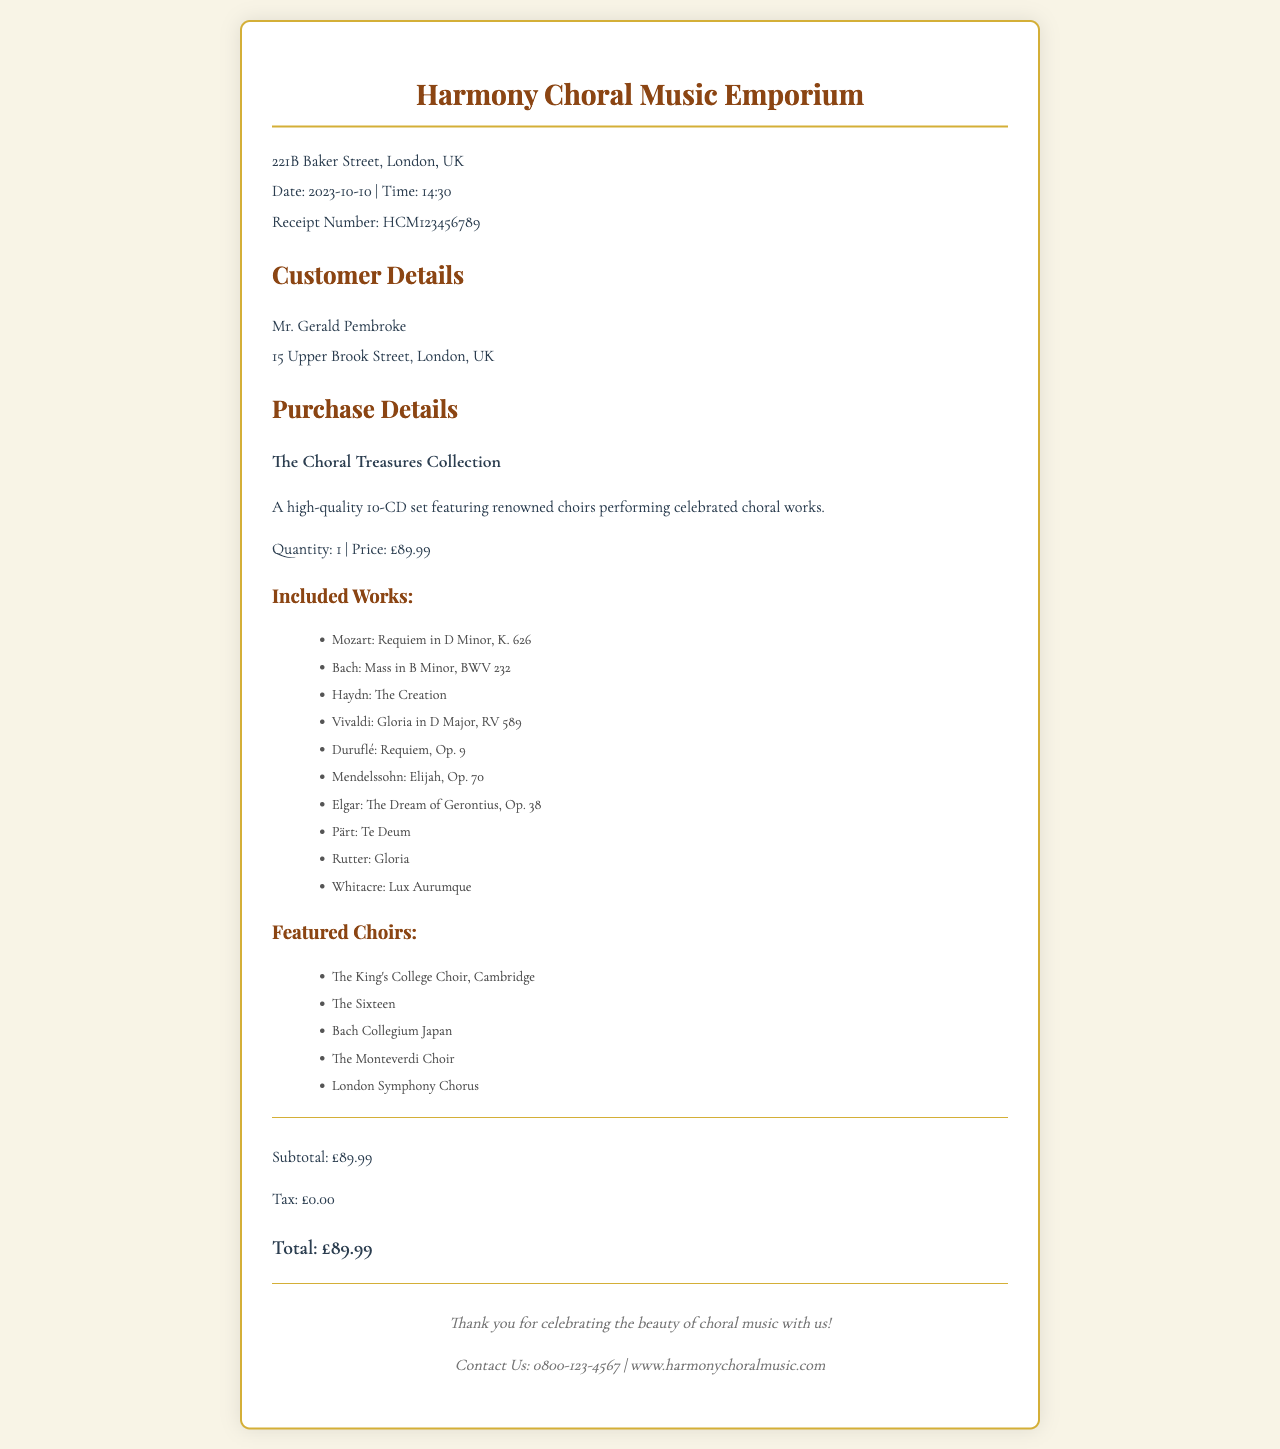What is the total price of the CD set? The total price is clearly listed in the totals section of the receipt.
Answer: £89.99 Who is the customer? The customer's name is mentioned in the customer details section of the receipt.
Answer: Mr. Gerald Pembroke What is the receipt number? The receipt number is provided in the header section of the receipt.
Answer: HCM123456789 How many CDs are in the collection? The number of CDs is stated in the item details section of the receipt.
Answer: 10 Which choir is featured first? The first choir mentioned in the featured choirs list gives insight into the selection's prestige.
Answer: The King's College Choir, Cambridge What is the address of the store? The store's address is included in the header of the receipt.
Answer: 221B Baker Street, London, UK What are the works included in the set? The included works section lists the musical pieces contained in the collection.
Answer: Mozart: Requiem in D Minor, K. 626 What type of music is featured in this receipt? The description in the item details indicates the genre of the purchased item.
Answer: Choral music How is the purchase detailed in the receipt? The purchase details section provides specific information about the item bought.
Answer: A high-quality 10-CD set featuring renowned choirs performing celebrated choral works 